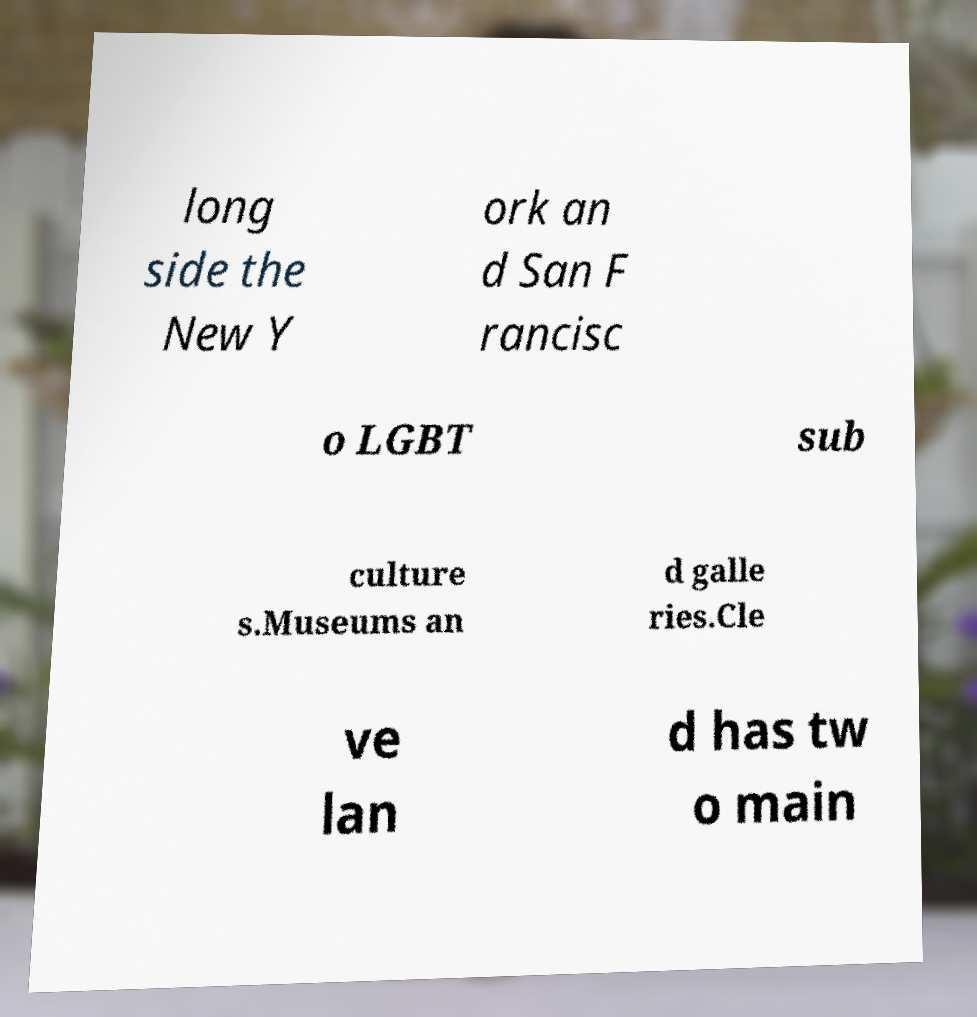Could you extract and type out the text from this image? long side the New Y ork an d San F rancisc o LGBT sub culture s.Museums an d galle ries.Cle ve lan d has tw o main 